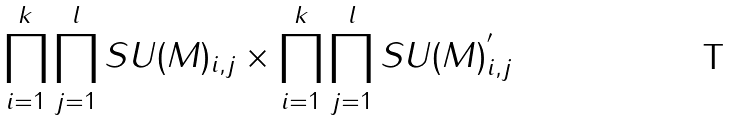<formula> <loc_0><loc_0><loc_500><loc_500>\prod _ { i = 1 } ^ { k } \prod _ { j = 1 } ^ { l } S U ( M ) _ { i , j } \times \prod _ { i = 1 } ^ { k } \prod _ { j = 1 } ^ { l } S U ( M ) _ { i , j } ^ { ^ { \prime } }</formula> 